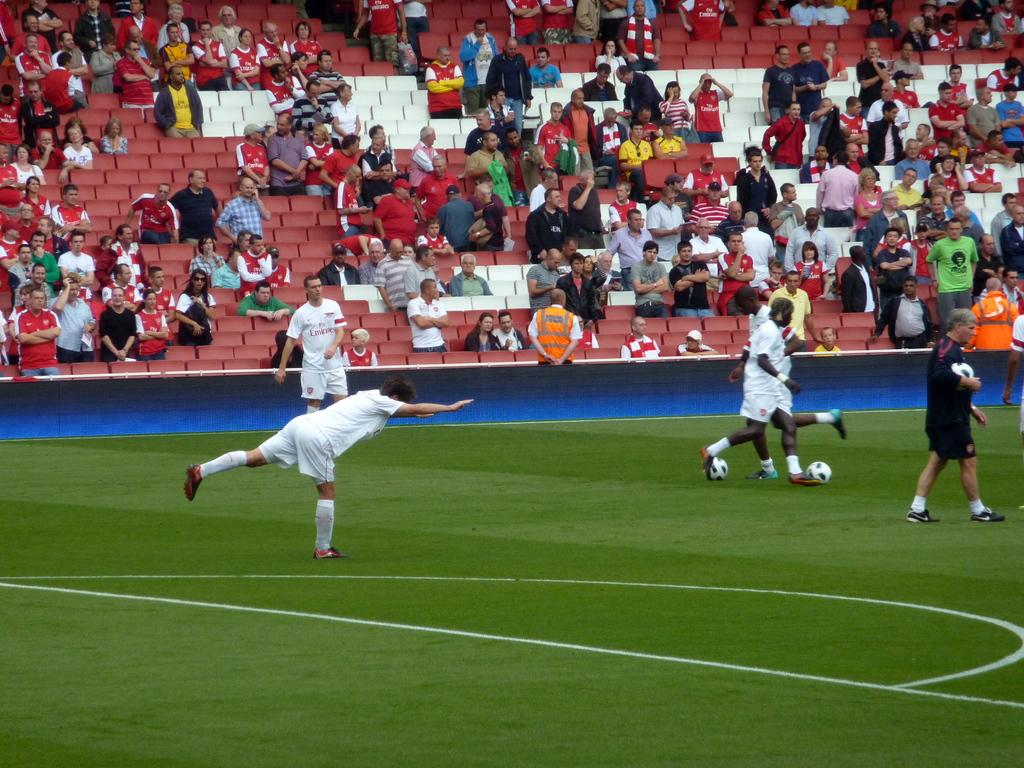What type of venue is the image taken in? The image is taken in a football stadium. What activity is taking place in the image? There are people playing football in the image. What can be seen in the background of the image? There are chairs in the background of the image. What is the color of the chairs? The chairs are red in color. Can you hear the band playing in the image? There is no band present in the image, so it is not possible to hear them playing. 